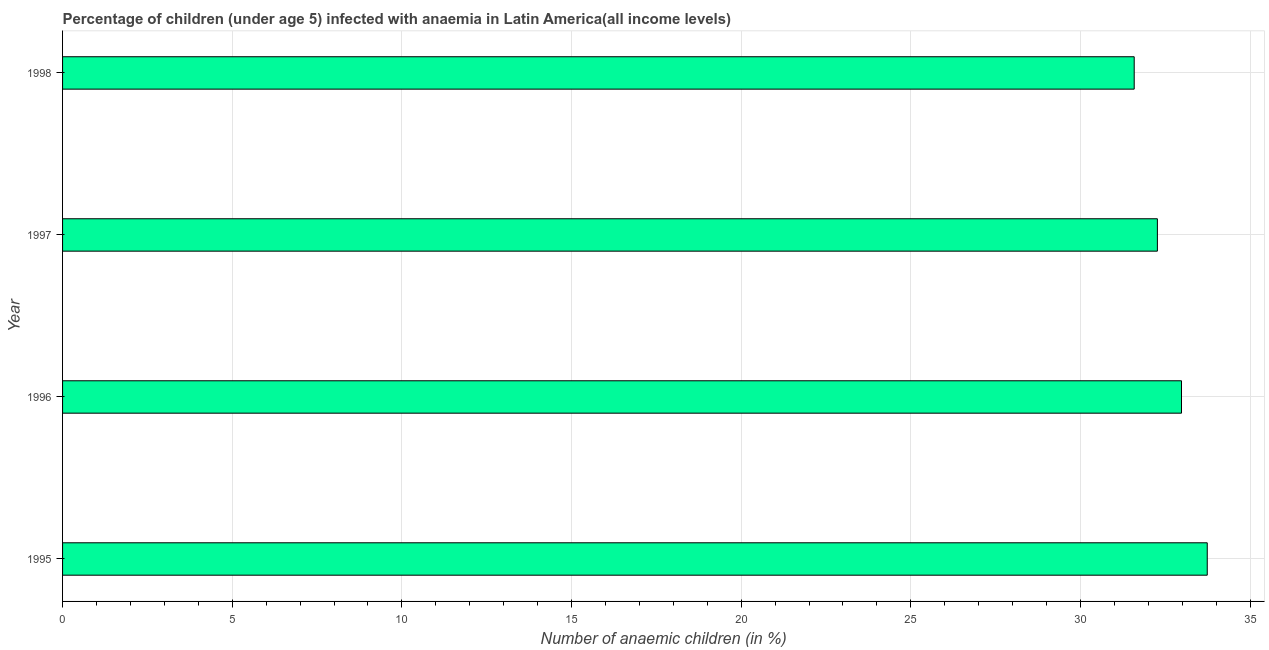What is the title of the graph?
Provide a succinct answer. Percentage of children (under age 5) infected with anaemia in Latin America(all income levels). What is the label or title of the X-axis?
Give a very brief answer. Number of anaemic children (in %). What is the number of anaemic children in 1995?
Provide a short and direct response. 33.74. Across all years, what is the maximum number of anaemic children?
Give a very brief answer. 33.74. Across all years, what is the minimum number of anaemic children?
Offer a terse response. 31.58. What is the sum of the number of anaemic children?
Provide a short and direct response. 130.56. What is the difference between the number of anaemic children in 1995 and 1996?
Provide a succinct answer. 0.76. What is the average number of anaemic children per year?
Make the answer very short. 32.64. What is the median number of anaemic children?
Ensure brevity in your answer.  32.62. In how many years, is the number of anaemic children greater than 1 %?
Your answer should be very brief. 4. What is the ratio of the number of anaemic children in 1996 to that in 1998?
Offer a very short reply. 1.04. What is the difference between the highest and the second highest number of anaemic children?
Your answer should be very brief. 0.76. Is the sum of the number of anaemic children in 1996 and 1998 greater than the maximum number of anaemic children across all years?
Provide a short and direct response. Yes. What is the difference between the highest and the lowest number of anaemic children?
Ensure brevity in your answer.  2.15. In how many years, is the number of anaemic children greater than the average number of anaemic children taken over all years?
Offer a terse response. 2. How many bars are there?
Offer a very short reply. 4. Are all the bars in the graph horizontal?
Offer a very short reply. Yes. How many years are there in the graph?
Your answer should be compact. 4. Are the values on the major ticks of X-axis written in scientific E-notation?
Keep it short and to the point. No. What is the Number of anaemic children (in %) in 1995?
Your response must be concise. 33.74. What is the Number of anaemic children (in %) of 1996?
Offer a terse response. 32.98. What is the Number of anaemic children (in %) in 1997?
Your answer should be compact. 32.27. What is the Number of anaemic children (in %) in 1998?
Give a very brief answer. 31.58. What is the difference between the Number of anaemic children (in %) in 1995 and 1996?
Provide a succinct answer. 0.76. What is the difference between the Number of anaemic children (in %) in 1995 and 1997?
Make the answer very short. 1.47. What is the difference between the Number of anaemic children (in %) in 1995 and 1998?
Your answer should be compact. 2.15. What is the difference between the Number of anaemic children (in %) in 1996 and 1997?
Your answer should be very brief. 0.71. What is the difference between the Number of anaemic children (in %) in 1996 and 1998?
Offer a very short reply. 1.39. What is the difference between the Number of anaemic children (in %) in 1997 and 1998?
Your answer should be compact. 0.68. What is the ratio of the Number of anaemic children (in %) in 1995 to that in 1997?
Your answer should be very brief. 1.05. What is the ratio of the Number of anaemic children (in %) in 1995 to that in 1998?
Offer a very short reply. 1.07. What is the ratio of the Number of anaemic children (in %) in 1996 to that in 1997?
Give a very brief answer. 1.02. What is the ratio of the Number of anaemic children (in %) in 1996 to that in 1998?
Give a very brief answer. 1.04. 